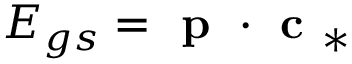Convert formula to latex. <formula><loc_0><loc_0><loc_500><loc_500>E _ { g s } = p \cdot c _ { * }</formula> 